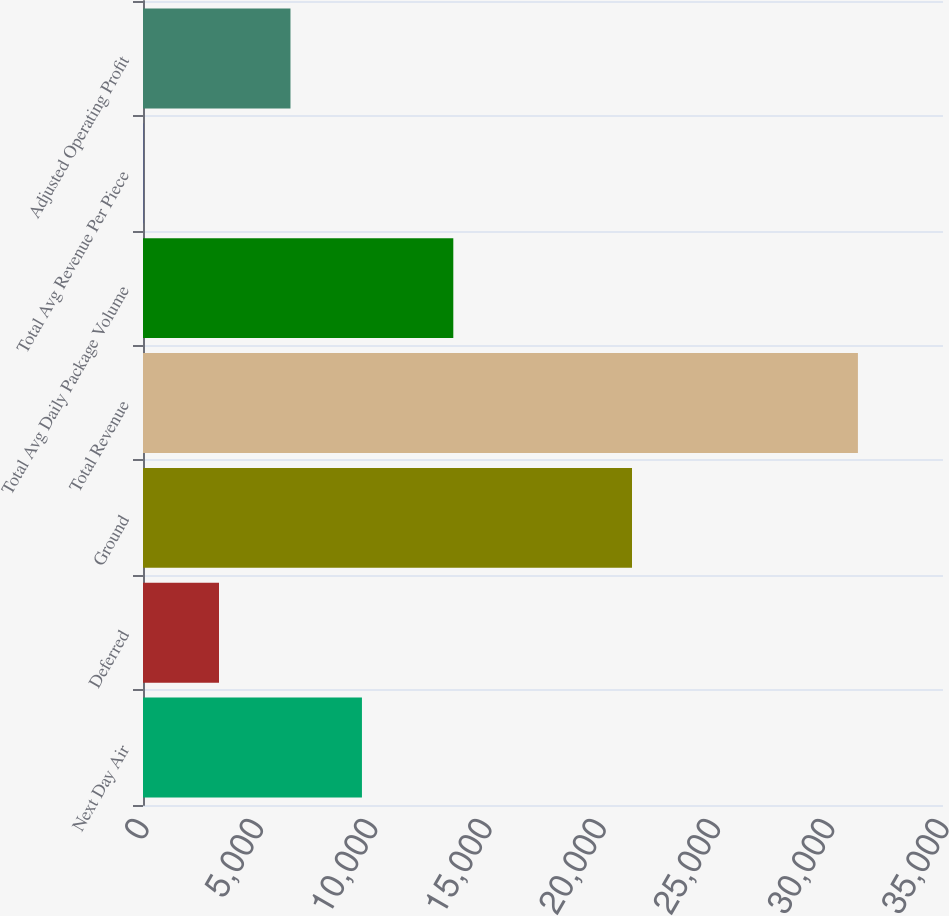Convert chart to OTSL. <chart><loc_0><loc_0><loc_500><loc_500><bar_chart><fcel>Next Day Air<fcel>Deferred<fcel>Ground<fcel>Total Revenue<fcel>Total Avg Daily Package Volume<fcel>Total Avg Revenue Per Piece<fcel>Adjusted Operating Profit<nl><fcel>9578.78<fcel>3325<fcel>21394<fcel>31278<fcel>13576<fcel>9.14<fcel>6451.89<nl></chart> 